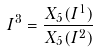Convert formula to latex. <formula><loc_0><loc_0><loc_500><loc_500>I ^ { 3 } = \frac { X _ { 5 } ( I ^ { 1 } ) } { X _ { 5 } ( I ^ { 2 } ) }</formula> 